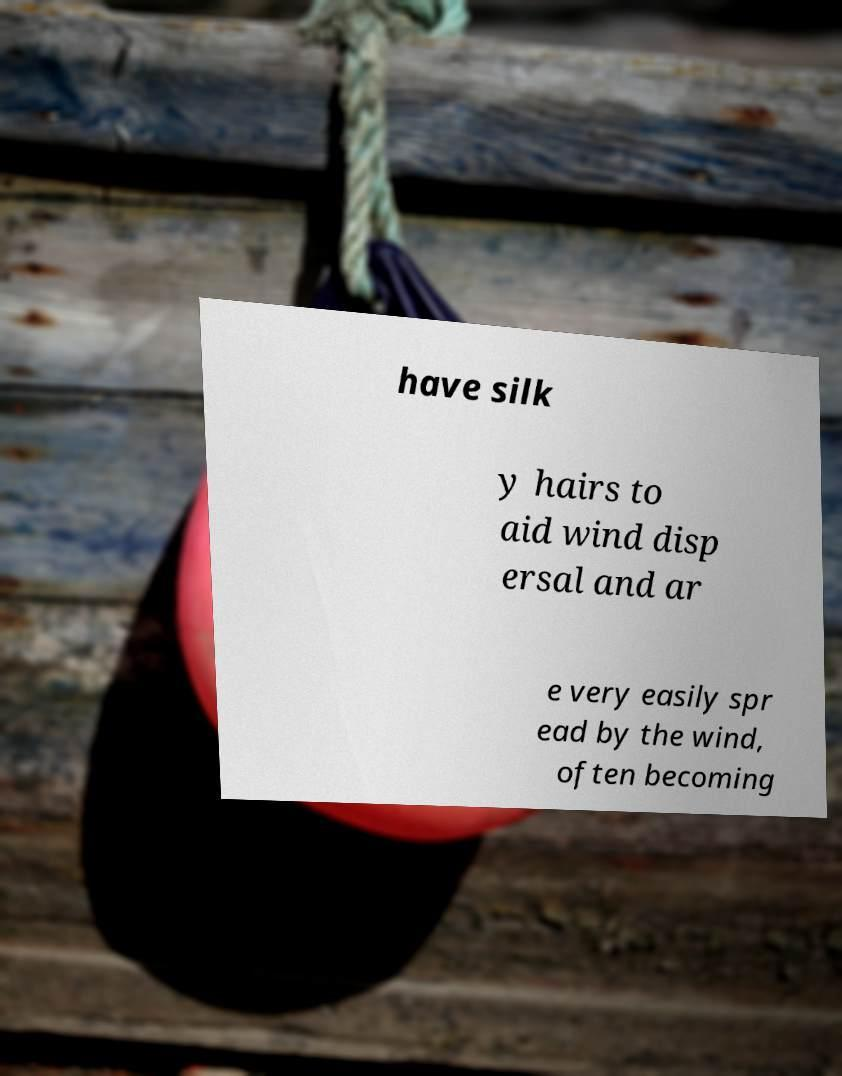Can you read and provide the text displayed in the image?This photo seems to have some interesting text. Can you extract and type it out for me? have silk y hairs to aid wind disp ersal and ar e very easily spr ead by the wind, often becoming 